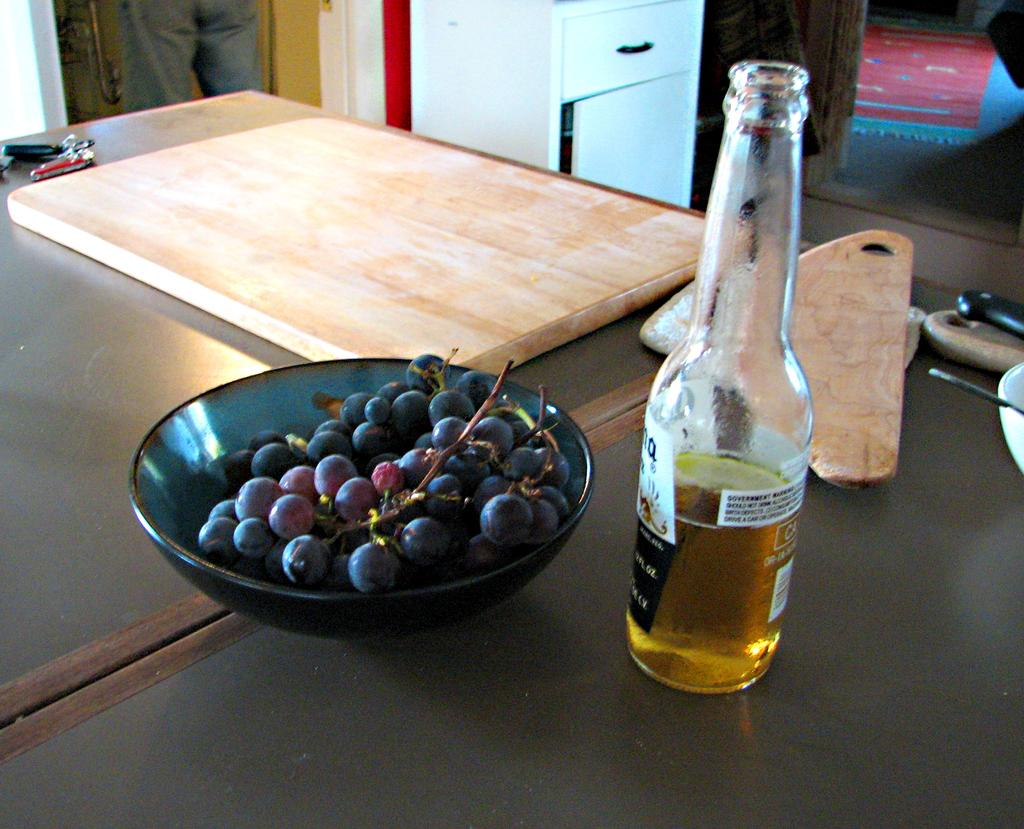What is in the bowl that is visible in the image? There is a bowl with grapes in the image. What other items can be seen in the image? There is a wine bottle, a chopping pad, and a key chain visible in the image. Where are these objects located? These objects are on a table in the image. What else is present in the image? There is a cupboard and a person's legs visible in the image. What type of snake can be seen slithering across the table in the image? There is no snake present in the image. 